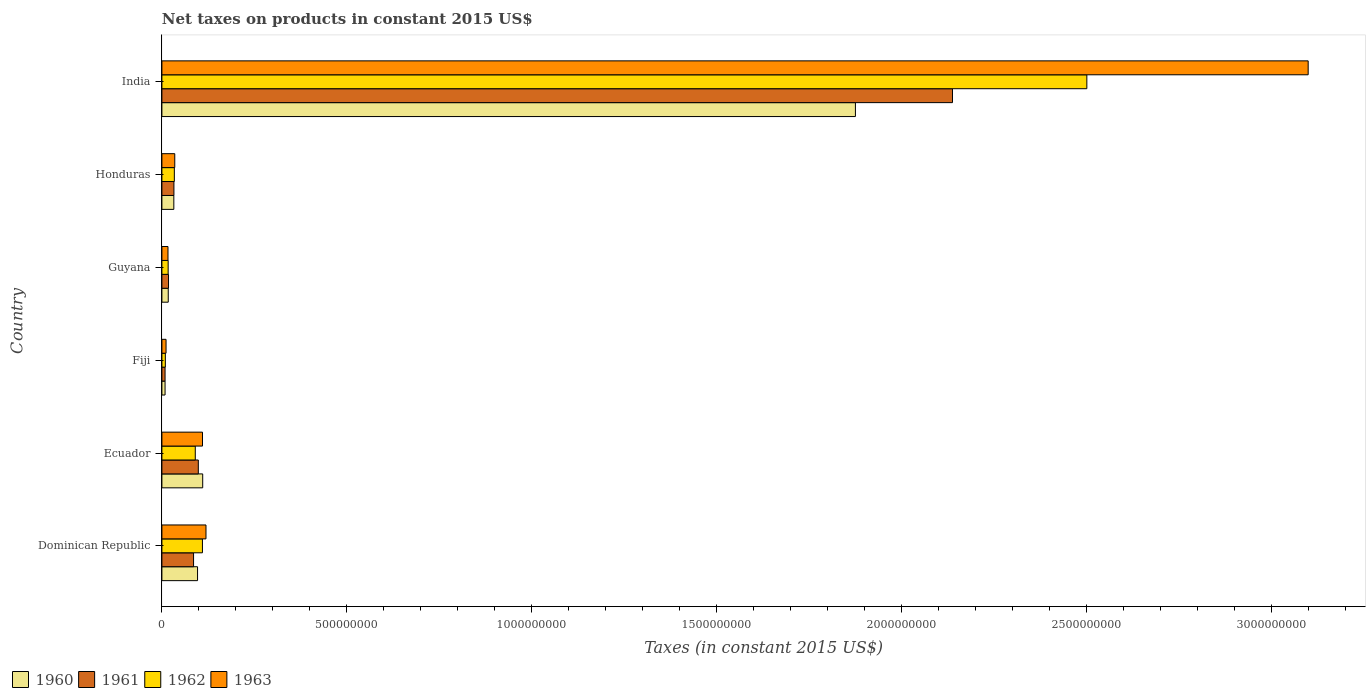Are the number of bars on each tick of the Y-axis equal?
Keep it short and to the point. Yes. How many bars are there on the 2nd tick from the top?
Keep it short and to the point. 4. In how many cases, is the number of bars for a given country not equal to the number of legend labels?
Give a very brief answer. 0. What is the net taxes on products in 1960 in Fiji?
Offer a very short reply. 8.56e+06. Across all countries, what is the maximum net taxes on products in 1963?
Keep it short and to the point. 3.10e+09. Across all countries, what is the minimum net taxes on products in 1960?
Your answer should be very brief. 8.56e+06. In which country was the net taxes on products in 1962 maximum?
Give a very brief answer. India. In which country was the net taxes on products in 1961 minimum?
Provide a short and direct response. Fiji. What is the total net taxes on products in 1962 in the graph?
Your answer should be very brief. 2.76e+09. What is the difference between the net taxes on products in 1963 in Dominican Republic and that in Ecuador?
Keep it short and to the point. 9.44e+06. What is the difference between the net taxes on products in 1960 in India and the net taxes on products in 1962 in Honduras?
Offer a very short reply. 1.84e+09. What is the average net taxes on products in 1963 per country?
Your answer should be compact. 5.65e+08. What is the difference between the net taxes on products in 1963 and net taxes on products in 1961 in Guyana?
Give a very brief answer. -1.46e+06. In how many countries, is the net taxes on products in 1961 greater than 2600000000 US$?
Provide a short and direct response. 0. What is the ratio of the net taxes on products in 1960 in Dominican Republic to that in Honduras?
Provide a short and direct response. 2.99. Is the net taxes on products in 1962 in Fiji less than that in India?
Provide a succinct answer. Yes. Is the difference between the net taxes on products in 1963 in Honduras and India greater than the difference between the net taxes on products in 1961 in Honduras and India?
Make the answer very short. No. What is the difference between the highest and the second highest net taxes on products in 1962?
Your answer should be very brief. 2.39e+09. What is the difference between the highest and the lowest net taxes on products in 1962?
Ensure brevity in your answer.  2.49e+09. Is the sum of the net taxes on products in 1963 in Dominican Republic and India greater than the maximum net taxes on products in 1961 across all countries?
Your response must be concise. Yes. Is it the case that in every country, the sum of the net taxes on products in 1962 and net taxes on products in 1960 is greater than the sum of net taxes on products in 1963 and net taxes on products in 1961?
Your answer should be compact. No. What does the 2nd bar from the bottom in Honduras represents?
Give a very brief answer. 1961. Is it the case that in every country, the sum of the net taxes on products in 1963 and net taxes on products in 1960 is greater than the net taxes on products in 1961?
Ensure brevity in your answer.  Yes. How many bars are there?
Provide a short and direct response. 24. Are all the bars in the graph horizontal?
Give a very brief answer. Yes. How many countries are there in the graph?
Make the answer very short. 6. What is the difference between two consecutive major ticks on the X-axis?
Your answer should be very brief. 5.00e+08. Does the graph contain grids?
Provide a short and direct response. No. What is the title of the graph?
Give a very brief answer. Net taxes on products in constant 2015 US$. What is the label or title of the X-axis?
Provide a short and direct response. Taxes (in constant 2015 US$). What is the Taxes (in constant 2015 US$) of 1960 in Dominican Republic?
Keep it short and to the point. 9.64e+07. What is the Taxes (in constant 2015 US$) of 1961 in Dominican Republic?
Give a very brief answer. 8.56e+07. What is the Taxes (in constant 2015 US$) in 1962 in Dominican Republic?
Provide a succinct answer. 1.10e+08. What is the Taxes (in constant 2015 US$) in 1963 in Dominican Republic?
Offer a very short reply. 1.19e+08. What is the Taxes (in constant 2015 US$) of 1960 in Ecuador?
Keep it short and to the point. 1.10e+08. What is the Taxes (in constant 2015 US$) in 1961 in Ecuador?
Ensure brevity in your answer.  9.85e+07. What is the Taxes (in constant 2015 US$) in 1962 in Ecuador?
Give a very brief answer. 9.03e+07. What is the Taxes (in constant 2015 US$) in 1963 in Ecuador?
Your answer should be very brief. 1.10e+08. What is the Taxes (in constant 2015 US$) of 1960 in Fiji?
Offer a very short reply. 8.56e+06. What is the Taxes (in constant 2015 US$) of 1961 in Fiji?
Your response must be concise. 8.56e+06. What is the Taxes (in constant 2015 US$) of 1962 in Fiji?
Provide a succinct answer. 9.32e+06. What is the Taxes (in constant 2015 US$) in 1963 in Fiji?
Ensure brevity in your answer.  1.12e+07. What is the Taxes (in constant 2015 US$) in 1960 in Guyana?
Provide a succinct answer. 1.71e+07. What is the Taxes (in constant 2015 US$) in 1961 in Guyana?
Your answer should be compact. 1.79e+07. What is the Taxes (in constant 2015 US$) of 1962 in Guyana?
Your response must be concise. 1.69e+07. What is the Taxes (in constant 2015 US$) of 1963 in Guyana?
Provide a short and direct response. 1.64e+07. What is the Taxes (in constant 2015 US$) of 1960 in Honduras?
Offer a very short reply. 3.22e+07. What is the Taxes (in constant 2015 US$) in 1961 in Honduras?
Make the answer very short. 3.25e+07. What is the Taxes (in constant 2015 US$) in 1962 in Honduras?
Ensure brevity in your answer.  3.36e+07. What is the Taxes (in constant 2015 US$) in 1963 in Honduras?
Give a very brief answer. 3.48e+07. What is the Taxes (in constant 2015 US$) in 1960 in India?
Make the answer very short. 1.88e+09. What is the Taxes (in constant 2015 US$) in 1961 in India?
Ensure brevity in your answer.  2.14e+09. What is the Taxes (in constant 2015 US$) in 1962 in India?
Your answer should be very brief. 2.50e+09. What is the Taxes (in constant 2015 US$) in 1963 in India?
Make the answer very short. 3.10e+09. Across all countries, what is the maximum Taxes (in constant 2015 US$) in 1960?
Your answer should be compact. 1.88e+09. Across all countries, what is the maximum Taxes (in constant 2015 US$) in 1961?
Your response must be concise. 2.14e+09. Across all countries, what is the maximum Taxes (in constant 2015 US$) of 1962?
Your response must be concise. 2.50e+09. Across all countries, what is the maximum Taxes (in constant 2015 US$) in 1963?
Give a very brief answer. 3.10e+09. Across all countries, what is the minimum Taxes (in constant 2015 US$) in 1960?
Your response must be concise. 8.56e+06. Across all countries, what is the minimum Taxes (in constant 2015 US$) in 1961?
Offer a very short reply. 8.56e+06. Across all countries, what is the minimum Taxes (in constant 2015 US$) of 1962?
Offer a very short reply. 9.32e+06. Across all countries, what is the minimum Taxes (in constant 2015 US$) of 1963?
Offer a terse response. 1.12e+07. What is the total Taxes (in constant 2015 US$) of 1960 in the graph?
Ensure brevity in your answer.  2.14e+09. What is the total Taxes (in constant 2015 US$) of 1961 in the graph?
Your response must be concise. 2.38e+09. What is the total Taxes (in constant 2015 US$) of 1962 in the graph?
Provide a short and direct response. 2.76e+09. What is the total Taxes (in constant 2015 US$) in 1963 in the graph?
Your response must be concise. 3.39e+09. What is the difference between the Taxes (in constant 2015 US$) of 1960 in Dominican Republic and that in Ecuador?
Your answer should be very brief. -1.39e+07. What is the difference between the Taxes (in constant 2015 US$) in 1961 in Dominican Republic and that in Ecuador?
Your answer should be compact. -1.29e+07. What is the difference between the Taxes (in constant 2015 US$) in 1962 in Dominican Republic and that in Ecuador?
Provide a short and direct response. 1.93e+07. What is the difference between the Taxes (in constant 2015 US$) in 1963 in Dominican Republic and that in Ecuador?
Give a very brief answer. 9.44e+06. What is the difference between the Taxes (in constant 2015 US$) of 1960 in Dominican Republic and that in Fiji?
Provide a succinct answer. 8.78e+07. What is the difference between the Taxes (in constant 2015 US$) of 1961 in Dominican Republic and that in Fiji?
Ensure brevity in your answer.  7.70e+07. What is the difference between the Taxes (in constant 2015 US$) of 1962 in Dominican Republic and that in Fiji?
Give a very brief answer. 1.00e+08. What is the difference between the Taxes (in constant 2015 US$) in 1963 in Dominican Republic and that in Fiji?
Offer a terse response. 1.08e+08. What is the difference between the Taxes (in constant 2015 US$) in 1960 in Dominican Republic and that in Guyana?
Offer a terse response. 7.93e+07. What is the difference between the Taxes (in constant 2015 US$) in 1961 in Dominican Republic and that in Guyana?
Make the answer very short. 6.77e+07. What is the difference between the Taxes (in constant 2015 US$) of 1962 in Dominican Republic and that in Guyana?
Ensure brevity in your answer.  9.27e+07. What is the difference between the Taxes (in constant 2015 US$) of 1963 in Dominican Republic and that in Guyana?
Provide a succinct answer. 1.03e+08. What is the difference between the Taxes (in constant 2015 US$) of 1960 in Dominican Republic and that in Honduras?
Provide a short and direct response. 6.42e+07. What is the difference between the Taxes (in constant 2015 US$) of 1961 in Dominican Republic and that in Honduras?
Your answer should be very brief. 5.31e+07. What is the difference between the Taxes (in constant 2015 US$) in 1962 in Dominican Republic and that in Honduras?
Provide a short and direct response. 7.60e+07. What is the difference between the Taxes (in constant 2015 US$) in 1963 in Dominican Republic and that in Honduras?
Your response must be concise. 8.44e+07. What is the difference between the Taxes (in constant 2015 US$) of 1960 in Dominican Republic and that in India?
Give a very brief answer. -1.78e+09. What is the difference between the Taxes (in constant 2015 US$) in 1961 in Dominican Republic and that in India?
Offer a very short reply. -2.05e+09. What is the difference between the Taxes (in constant 2015 US$) of 1962 in Dominican Republic and that in India?
Ensure brevity in your answer.  -2.39e+09. What is the difference between the Taxes (in constant 2015 US$) in 1963 in Dominican Republic and that in India?
Your answer should be very brief. -2.98e+09. What is the difference between the Taxes (in constant 2015 US$) in 1960 in Ecuador and that in Fiji?
Offer a terse response. 1.02e+08. What is the difference between the Taxes (in constant 2015 US$) of 1961 in Ecuador and that in Fiji?
Provide a short and direct response. 8.99e+07. What is the difference between the Taxes (in constant 2015 US$) of 1962 in Ecuador and that in Fiji?
Make the answer very short. 8.09e+07. What is the difference between the Taxes (in constant 2015 US$) in 1963 in Ecuador and that in Fiji?
Provide a short and direct response. 9.86e+07. What is the difference between the Taxes (in constant 2015 US$) of 1960 in Ecuador and that in Guyana?
Provide a succinct answer. 9.32e+07. What is the difference between the Taxes (in constant 2015 US$) in 1961 in Ecuador and that in Guyana?
Your answer should be very brief. 8.06e+07. What is the difference between the Taxes (in constant 2015 US$) of 1962 in Ecuador and that in Guyana?
Keep it short and to the point. 7.33e+07. What is the difference between the Taxes (in constant 2015 US$) in 1963 in Ecuador and that in Guyana?
Give a very brief answer. 9.33e+07. What is the difference between the Taxes (in constant 2015 US$) of 1960 in Ecuador and that in Honduras?
Offer a very short reply. 7.81e+07. What is the difference between the Taxes (in constant 2015 US$) of 1961 in Ecuador and that in Honduras?
Keep it short and to the point. 6.60e+07. What is the difference between the Taxes (in constant 2015 US$) in 1962 in Ecuador and that in Honduras?
Your answer should be compact. 5.66e+07. What is the difference between the Taxes (in constant 2015 US$) in 1963 in Ecuador and that in Honduras?
Your response must be concise. 7.50e+07. What is the difference between the Taxes (in constant 2015 US$) in 1960 in Ecuador and that in India?
Your answer should be compact. -1.76e+09. What is the difference between the Taxes (in constant 2015 US$) of 1961 in Ecuador and that in India?
Provide a succinct answer. -2.04e+09. What is the difference between the Taxes (in constant 2015 US$) of 1962 in Ecuador and that in India?
Offer a very short reply. -2.41e+09. What is the difference between the Taxes (in constant 2015 US$) of 1963 in Ecuador and that in India?
Your answer should be very brief. -2.99e+09. What is the difference between the Taxes (in constant 2015 US$) in 1960 in Fiji and that in Guyana?
Provide a succinct answer. -8.59e+06. What is the difference between the Taxes (in constant 2015 US$) of 1961 in Fiji and that in Guyana?
Provide a succinct answer. -9.34e+06. What is the difference between the Taxes (in constant 2015 US$) of 1962 in Fiji and that in Guyana?
Your answer should be compact. -7.60e+06. What is the difference between the Taxes (in constant 2015 US$) of 1963 in Fiji and that in Guyana?
Your response must be concise. -5.24e+06. What is the difference between the Taxes (in constant 2015 US$) in 1960 in Fiji and that in Honduras?
Keep it short and to the point. -2.37e+07. What is the difference between the Taxes (in constant 2015 US$) in 1961 in Fiji and that in Honduras?
Provide a succinct answer. -2.39e+07. What is the difference between the Taxes (in constant 2015 US$) in 1962 in Fiji and that in Honduras?
Your answer should be compact. -2.43e+07. What is the difference between the Taxes (in constant 2015 US$) in 1963 in Fiji and that in Honduras?
Offer a very short reply. -2.36e+07. What is the difference between the Taxes (in constant 2015 US$) of 1960 in Fiji and that in India?
Provide a succinct answer. -1.87e+09. What is the difference between the Taxes (in constant 2015 US$) of 1961 in Fiji and that in India?
Provide a short and direct response. -2.13e+09. What is the difference between the Taxes (in constant 2015 US$) in 1962 in Fiji and that in India?
Your answer should be very brief. -2.49e+09. What is the difference between the Taxes (in constant 2015 US$) of 1963 in Fiji and that in India?
Offer a very short reply. -3.09e+09. What is the difference between the Taxes (in constant 2015 US$) of 1960 in Guyana and that in Honduras?
Give a very brief answer. -1.51e+07. What is the difference between the Taxes (in constant 2015 US$) in 1961 in Guyana and that in Honduras?
Give a very brief answer. -1.46e+07. What is the difference between the Taxes (in constant 2015 US$) of 1962 in Guyana and that in Honduras?
Your answer should be very brief. -1.67e+07. What is the difference between the Taxes (in constant 2015 US$) of 1963 in Guyana and that in Honduras?
Provide a short and direct response. -1.84e+07. What is the difference between the Taxes (in constant 2015 US$) in 1960 in Guyana and that in India?
Offer a very short reply. -1.86e+09. What is the difference between the Taxes (in constant 2015 US$) of 1961 in Guyana and that in India?
Your answer should be very brief. -2.12e+09. What is the difference between the Taxes (in constant 2015 US$) of 1962 in Guyana and that in India?
Offer a terse response. -2.48e+09. What is the difference between the Taxes (in constant 2015 US$) in 1963 in Guyana and that in India?
Ensure brevity in your answer.  -3.08e+09. What is the difference between the Taxes (in constant 2015 US$) in 1960 in Honduras and that in India?
Make the answer very short. -1.84e+09. What is the difference between the Taxes (in constant 2015 US$) of 1961 in Honduras and that in India?
Give a very brief answer. -2.11e+09. What is the difference between the Taxes (in constant 2015 US$) in 1962 in Honduras and that in India?
Provide a succinct answer. -2.47e+09. What is the difference between the Taxes (in constant 2015 US$) in 1963 in Honduras and that in India?
Give a very brief answer. -3.06e+09. What is the difference between the Taxes (in constant 2015 US$) of 1960 in Dominican Republic and the Taxes (in constant 2015 US$) of 1961 in Ecuador?
Your answer should be compact. -2.07e+06. What is the difference between the Taxes (in constant 2015 US$) in 1960 in Dominican Republic and the Taxes (in constant 2015 US$) in 1962 in Ecuador?
Make the answer very short. 6.14e+06. What is the difference between the Taxes (in constant 2015 US$) in 1960 in Dominican Republic and the Taxes (in constant 2015 US$) in 1963 in Ecuador?
Provide a succinct answer. -1.34e+07. What is the difference between the Taxes (in constant 2015 US$) of 1961 in Dominican Republic and the Taxes (in constant 2015 US$) of 1962 in Ecuador?
Give a very brief answer. -4.66e+06. What is the difference between the Taxes (in constant 2015 US$) of 1961 in Dominican Republic and the Taxes (in constant 2015 US$) of 1963 in Ecuador?
Your response must be concise. -2.42e+07. What is the difference between the Taxes (in constant 2015 US$) of 1962 in Dominican Republic and the Taxes (in constant 2015 US$) of 1963 in Ecuador?
Make the answer very short. -1.64e+05. What is the difference between the Taxes (in constant 2015 US$) in 1960 in Dominican Republic and the Taxes (in constant 2015 US$) in 1961 in Fiji?
Offer a very short reply. 8.78e+07. What is the difference between the Taxes (in constant 2015 US$) of 1960 in Dominican Republic and the Taxes (in constant 2015 US$) of 1962 in Fiji?
Ensure brevity in your answer.  8.71e+07. What is the difference between the Taxes (in constant 2015 US$) in 1960 in Dominican Republic and the Taxes (in constant 2015 US$) in 1963 in Fiji?
Give a very brief answer. 8.52e+07. What is the difference between the Taxes (in constant 2015 US$) of 1961 in Dominican Republic and the Taxes (in constant 2015 US$) of 1962 in Fiji?
Your answer should be very brief. 7.63e+07. What is the difference between the Taxes (in constant 2015 US$) in 1961 in Dominican Republic and the Taxes (in constant 2015 US$) in 1963 in Fiji?
Provide a succinct answer. 7.44e+07. What is the difference between the Taxes (in constant 2015 US$) in 1962 in Dominican Republic and the Taxes (in constant 2015 US$) in 1963 in Fiji?
Keep it short and to the point. 9.84e+07. What is the difference between the Taxes (in constant 2015 US$) in 1960 in Dominican Republic and the Taxes (in constant 2015 US$) in 1961 in Guyana?
Keep it short and to the point. 7.85e+07. What is the difference between the Taxes (in constant 2015 US$) of 1960 in Dominican Republic and the Taxes (in constant 2015 US$) of 1962 in Guyana?
Your response must be concise. 7.95e+07. What is the difference between the Taxes (in constant 2015 US$) in 1960 in Dominican Republic and the Taxes (in constant 2015 US$) in 1963 in Guyana?
Ensure brevity in your answer.  8.00e+07. What is the difference between the Taxes (in constant 2015 US$) in 1961 in Dominican Republic and the Taxes (in constant 2015 US$) in 1962 in Guyana?
Give a very brief answer. 6.87e+07. What is the difference between the Taxes (in constant 2015 US$) in 1961 in Dominican Republic and the Taxes (in constant 2015 US$) in 1963 in Guyana?
Keep it short and to the point. 6.92e+07. What is the difference between the Taxes (in constant 2015 US$) of 1962 in Dominican Republic and the Taxes (in constant 2015 US$) of 1963 in Guyana?
Your answer should be compact. 9.32e+07. What is the difference between the Taxes (in constant 2015 US$) of 1960 in Dominican Republic and the Taxes (in constant 2015 US$) of 1961 in Honduras?
Your answer should be compact. 6.39e+07. What is the difference between the Taxes (in constant 2015 US$) in 1960 in Dominican Republic and the Taxes (in constant 2015 US$) in 1962 in Honduras?
Keep it short and to the point. 6.28e+07. What is the difference between the Taxes (in constant 2015 US$) of 1960 in Dominican Republic and the Taxes (in constant 2015 US$) of 1963 in Honduras?
Provide a short and direct response. 6.16e+07. What is the difference between the Taxes (in constant 2015 US$) in 1961 in Dominican Republic and the Taxes (in constant 2015 US$) in 1962 in Honduras?
Your answer should be compact. 5.20e+07. What is the difference between the Taxes (in constant 2015 US$) in 1961 in Dominican Republic and the Taxes (in constant 2015 US$) in 1963 in Honduras?
Provide a succinct answer. 5.08e+07. What is the difference between the Taxes (in constant 2015 US$) in 1962 in Dominican Republic and the Taxes (in constant 2015 US$) in 1963 in Honduras?
Provide a short and direct response. 7.48e+07. What is the difference between the Taxes (in constant 2015 US$) of 1960 in Dominican Republic and the Taxes (in constant 2015 US$) of 1961 in India?
Ensure brevity in your answer.  -2.04e+09. What is the difference between the Taxes (in constant 2015 US$) in 1960 in Dominican Republic and the Taxes (in constant 2015 US$) in 1962 in India?
Give a very brief answer. -2.40e+09. What is the difference between the Taxes (in constant 2015 US$) in 1960 in Dominican Republic and the Taxes (in constant 2015 US$) in 1963 in India?
Provide a succinct answer. -3.00e+09. What is the difference between the Taxes (in constant 2015 US$) in 1961 in Dominican Republic and the Taxes (in constant 2015 US$) in 1962 in India?
Offer a terse response. -2.42e+09. What is the difference between the Taxes (in constant 2015 US$) of 1961 in Dominican Republic and the Taxes (in constant 2015 US$) of 1963 in India?
Ensure brevity in your answer.  -3.01e+09. What is the difference between the Taxes (in constant 2015 US$) in 1962 in Dominican Republic and the Taxes (in constant 2015 US$) in 1963 in India?
Your answer should be very brief. -2.99e+09. What is the difference between the Taxes (in constant 2015 US$) of 1960 in Ecuador and the Taxes (in constant 2015 US$) of 1961 in Fiji?
Your answer should be very brief. 1.02e+08. What is the difference between the Taxes (in constant 2015 US$) in 1960 in Ecuador and the Taxes (in constant 2015 US$) in 1962 in Fiji?
Your answer should be compact. 1.01e+08. What is the difference between the Taxes (in constant 2015 US$) in 1960 in Ecuador and the Taxes (in constant 2015 US$) in 1963 in Fiji?
Provide a short and direct response. 9.91e+07. What is the difference between the Taxes (in constant 2015 US$) in 1961 in Ecuador and the Taxes (in constant 2015 US$) in 1962 in Fiji?
Offer a terse response. 8.91e+07. What is the difference between the Taxes (in constant 2015 US$) in 1961 in Ecuador and the Taxes (in constant 2015 US$) in 1963 in Fiji?
Make the answer very short. 8.73e+07. What is the difference between the Taxes (in constant 2015 US$) of 1962 in Ecuador and the Taxes (in constant 2015 US$) of 1963 in Fiji?
Your answer should be very brief. 7.91e+07. What is the difference between the Taxes (in constant 2015 US$) of 1960 in Ecuador and the Taxes (in constant 2015 US$) of 1961 in Guyana?
Give a very brief answer. 9.24e+07. What is the difference between the Taxes (in constant 2015 US$) of 1960 in Ecuador and the Taxes (in constant 2015 US$) of 1962 in Guyana?
Ensure brevity in your answer.  9.34e+07. What is the difference between the Taxes (in constant 2015 US$) in 1960 in Ecuador and the Taxes (in constant 2015 US$) in 1963 in Guyana?
Your response must be concise. 9.39e+07. What is the difference between the Taxes (in constant 2015 US$) in 1961 in Ecuador and the Taxes (in constant 2015 US$) in 1962 in Guyana?
Keep it short and to the point. 8.16e+07. What is the difference between the Taxes (in constant 2015 US$) of 1961 in Ecuador and the Taxes (in constant 2015 US$) of 1963 in Guyana?
Your answer should be very brief. 8.20e+07. What is the difference between the Taxes (in constant 2015 US$) of 1962 in Ecuador and the Taxes (in constant 2015 US$) of 1963 in Guyana?
Offer a very short reply. 7.38e+07. What is the difference between the Taxes (in constant 2015 US$) in 1960 in Ecuador and the Taxes (in constant 2015 US$) in 1961 in Honduras?
Keep it short and to the point. 7.78e+07. What is the difference between the Taxes (in constant 2015 US$) of 1960 in Ecuador and the Taxes (in constant 2015 US$) of 1962 in Honduras?
Offer a very short reply. 7.67e+07. What is the difference between the Taxes (in constant 2015 US$) in 1960 in Ecuador and the Taxes (in constant 2015 US$) in 1963 in Honduras?
Ensure brevity in your answer.  7.55e+07. What is the difference between the Taxes (in constant 2015 US$) of 1961 in Ecuador and the Taxes (in constant 2015 US$) of 1962 in Honduras?
Provide a short and direct response. 6.48e+07. What is the difference between the Taxes (in constant 2015 US$) in 1961 in Ecuador and the Taxes (in constant 2015 US$) in 1963 in Honduras?
Ensure brevity in your answer.  6.37e+07. What is the difference between the Taxes (in constant 2015 US$) in 1962 in Ecuador and the Taxes (in constant 2015 US$) in 1963 in Honduras?
Offer a very short reply. 5.55e+07. What is the difference between the Taxes (in constant 2015 US$) in 1960 in Ecuador and the Taxes (in constant 2015 US$) in 1961 in India?
Provide a short and direct response. -2.03e+09. What is the difference between the Taxes (in constant 2015 US$) in 1960 in Ecuador and the Taxes (in constant 2015 US$) in 1962 in India?
Provide a short and direct response. -2.39e+09. What is the difference between the Taxes (in constant 2015 US$) in 1960 in Ecuador and the Taxes (in constant 2015 US$) in 1963 in India?
Make the answer very short. -2.99e+09. What is the difference between the Taxes (in constant 2015 US$) of 1961 in Ecuador and the Taxes (in constant 2015 US$) of 1962 in India?
Provide a succinct answer. -2.40e+09. What is the difference between the Taxes (in constant 2015 US$) of 1961 in Ecuador and the Taxes (in constant 2015 US$) of 1963 in India?
Offer a terse response. -3.00e+09. What is the difference between the Taxes (in constant 2015 US$) of 1962 in Ecuador and the Taxes (in constant 2015 US$) of 1963 in India?
Keep it short and to the point. -3.01e+09. What is the difference between the Taxes (in constant 2015 US$) in 1960 in Fiji and the Taxes (in constant 2015 US$) in 1961 in Guyana?
Your answer should be compact. -9.34e+06. What is the difference between the Taxes (in constant 2015 US$) of 1960 in Fiji and the Taxes (in constant 2015 US$) of 1962 in Guyana?
Your response must be concise. -8.35e+06. What is the difference between the Taxes (in constant 2015 US$) in 1960 in Fiji and the Taxes (in constant 2015 US$) in 1963 in Guyana?
Ensure brevity in your answer.  -7.89e+06. What is the difference between the Taxes (in constant 2015 US$) of 1961 in Fiji and the Taxes (in constant 2015 US$) of 1962 in Guyana?
Give a very brief answer. -8.35e+06. What is the difference between the Taxes (in constant 2015 US$) in 1961 in Fiji and the Taxes (in constant 2015 US$) in 1963 in Guyana?
Offer a very short reply. -7.89e+06. What is the difference between the Taxes (in constant 2015 US$) of 1962 in Fiji and the Taxes (in constant 2015 US$) of 1963 in Guyana?
Offer a terse response. -7.13e+06. What is the difference between the Taxes (in constant 2015 US$) of 1960 in Fiji and the Taxes (in constant 2015 US$) of 1961 in Honduras?
Offer a terse response. -2.39e+07. What is the difference between the Taxes (in constant 2015 US$) in 1960 in Fiji and the Taxes (in constant 2015 US$) in 1962 in Honduras?
Offer a terse response. -2.51e+07. What is the difference between the Taxes (in constant 2015 US$) in 1960 in Fiji and the Taxes (in constant 2015 US$) in 1963 in Honduras?
Offer a very short reply. -2.62e+07. What is the difference between the Taxes (in constant 2015 US$) in 1961 in Fiji and the Taxes (in constant 2015 US$) in 1962 in Honduras?
Your response must be concise. -2.51e+07. What is the difference between the Taxes (in constant 2015 US$) in 1961 in Fiji and the Taxes (in constant 2015 US$) in 1963 in Honduras?
Ensure brevity in your answer.  -2.62e+07. What is the difference between the Taxes (in constant 2015 US$) of 1962 in Fiji and the Taxes (in constant 2015 US$) of 1963 in Honduras?
Provide a succinct answer. -2.55e+07. What is the difference between the Taxes (in constant 2015 US$) in 1960 in Fiji and the Taxes (in constant 2015 US$) in 1961 in India?
Provide a succinct answer. -2.13e+09. What is the difference between the Taxes (in constant 2015 US$) of 1960 in Fiji and the Taxes (in constant 2015 US$) of 1962 in India?
Keep it short and to the point. -2.49e+09. What is the difference between the Taxes (in constant 2015 US$) in 1960 in Fiji and the Taxes (in constant 2015 US$) in 1963 in India?
Make the answer very short. -3.09e+09. What is the difference between the Taxes (in constant 2015 US$) of 1961 in Fiji and the Taxes (in constant 2015 US$) of 1962 in India?
Provide a succinct answer. -2.49e+09. What is the difference between the Taxes (in constant 2015 US$) in 1961 in Fiji and the Taxes (in constant 2015 US$) in 1963 in India?
Make the answer very short. -3.09e+09. What is the difference between the Taxes (in constant 2015 US$) of 1962 in Fiji and the Taxes (in constant 2015 US$) of 1963 in India?
Provide a succinct answer. -3.09e+09. What is the difference between the Taxes (in constant 2015 US$) in 1960 in Guyana and the Taxes (in constant 2015 US$) in 1961 in Honduras?
Provide a succinct answer. -1.54e+07. What is the difference between the Taxes (in constant 2015 US$) in 1960 in Guyana and the Taxes (in constant 2015 US$) in 1962 in Honduras?
Make the answer very short. -1.65e+07. What is the difference between the Taxes (in constant 2015 US$) of 1960 in Guyana and the Taxes (in constant 2015 US$) of 1963 in Honduras?
Your response must be concise. -1.77e+07. What is the difference between the Taxes (in constant 2015 US$) in 1961 in Guyana and the Taxes (in constant 2015 US$) in 1962 in Honduras?
Ensure brevity in your answer.  -1.57e+07. What is the difference between the Taxes (in constant 2015 US$) in 1961 in Guyana and the Taxes (in constant 2015 US$) in 1963 in Honduras?
Make the answer very short. -1.69e+07. What is the difference between the Taxes (in constant 2015 US$) in 1962 in Guyana and the Taxes (in constant 2015 US$) in 1963 in Honduras?
Offer a terse response. -1.79e+07. What is the difference between the Taxes (in constant 2015 US$) in 1960 in Guyana and the Taxes (in constant 2015 US$) in 1961 in India?
Ensure brevity in your answer.  -2.12e+09. What is the difference between the Taxes (in constant 2015 US$) of 1960 in Guyana and the Taxes (in constant 2015 US$) of 1962 in India?
Provide a short and direct response. -2.48e+09. What is the difference between the Taxes (in constant 2015 US$) of 1960 in Guyana and the Taxes (in constant 2015 US$) of 1963 in India?
Offer a terse response. -3.08e+09. What is the difference between the Taxes (in constant 2015 US$) in 1961 in Guyana and the Taxes (in constant 2015 US$) in 1962 in India?
Offer a very short reply. -2.48e+09. What is the difference between the Taxes (in constant 2015 US$) in 1961 in Guyana and the Taxes (in constant 2015 US$) in 1963 in India?
Provide a short and direct response. -3.08e+09. What is the difference between the Taxes (in constant 2015 US$) in 1962 in Guyana and the Taxes (in constant 2015 US$) in 1963 in India?
Make the answer very short. -3.08e+09. What is the difference between the Taxes (in constant 2015 US$) in 1960 in Honduras and the Taxes (in constant 2015 US$) in 1961 in India?
Keep it short and to the point. -2.11e+09. What is the difference between the Taxes (in constant 2015 US$) in 1960 in Honduras and the Taxes (in constant 2015 US$) in 1962 in India?
Ensure brevity in your answer.  -2.47e+09. What is the difference between the Taxes (in constant 2015 US$) of 1960 in Honduras and the Taxes (in constant 2015 US$) of 1963 in India?
Give a very brief answer. -3.07e+09. What is the difference between the Taxes (in constant 2015 US$) in 1961 in Honduras and the Taxes (in constant 2015 US$) in 1962 in India?
Make the answer very short. -2.47e+09. What is the difference between the Taxes (in constant 2015 US$) of 1961 in Honduras and the Taxes (in constant 2015 US$) of 1963 in India?
Your answer should be very brief. -3.07e+09. What is the difference between the Taxes (in constant 2015 US$) of 1962 in Honduras and the Taxes (in constant 2015 US$) of 1963 in India?
Offer a terse response. -3.07e+09. What is the average Taxes (in constant 2015 US$) in 1960 per country?
Provide a succinct answer. 3.57e+08. What is the average Taxes (in constant 2015 US$) of 1961 per country?
Give a very brief answer. 3.97e+08. What is the average Taxes (in constant 2015 US$) of 1962 per country?
Ensure brevity in your answer.  4.60e+08. What is the average Taxes (in constant 2015 US$) in 1963 per country?
Provide a succinct answer. 5.65e+08. What is the difference between the Taxes (in constant 2015 US$) of 1960 and Taxes (in constant 2015 US$) of 1961 in Dominican Republic?
Your response must be concise. 1.08e+07. What is the difference between the Taxes (in constant 2015 US$) in 1960 and Taxes (in constant 2015 US$) in 1962 in Dominican Republic?
Offer a very short reply. -1.32e+07. What is the difference between the Taxes (in constant 2015 US$) in 1960 and Taxes (in constant 2015 US$) in 1963 in Dominican Republic?
Provide a succinct answer. -2.28e+07. What is the difference between the Taxes (in constant 2015 US$) of 1961 and Taxes (in constant 2015 US$) of 1962 in Dominican Republic?
Offer a very short reply. -2.40e+07. What is the difference between the Taxes (in constant 2015 US$) in 1961 and Taxes (in constant 2015 US$) in 1963 in Dominican Republic?
Provide a succinct answer. -3.36e+07. What is the difference between the Taxes (in constant 2015 US$) in 1962 and Taxes (in constant 2015 US$) in 1963 in Dominican Republic?
Your response must be concise. -9.60e+06. What is the difference between the Taxes (in constant 2015 US$) of 1960 and Taxes (in constant 2015 US$) of 1961 in Ecuador?
Offer a terse response. 1.19e+07. What is the difference between the Taxes (in constant 2015 US$) in 1960 and Taxes (in constant 2015 US$) in 1962 in Ecuador?
Your answer should be very brief. 2.01e+07. What is the difference between the Taxes (in constant 2015 US$) of 1960 and Taxes (in constant 2015 US$) of 1963 in Ecuador?
Your response must be concise. 5.57e+05. What is the difference between the Taxes (in constant 2015 US$) in 1961 and Taxes (in constant 2015 US$) in 1962 in Ecuador?
Provide a succinct answer. 8.21e+06. What is the difference between the Taxes (in constant 2015 US$) in 1961 and Taxes (in constant 2015 US$) in 1963 in Ecuador?
Your response must be concise. -1.13e+07. What is the difference between the Taxes (in constant 2015 US$) in 1962 and Taxes (in constant 2015 US$) in 1963 in Ecuador?
Provide a succinct answer. -1.95e+07. What is the difference between the Taxes (in constant 2015 US$) in 1960 and Taxes (in constant 2015 US$) in 1962 in Fiji?
Offer a very short reply. -7.56e+05. What is the difference between the Taxes (in constant 2015 US$) of 1960 and Taxes (in constant 2015 US$) of 1963 in Fiji?
Your answer should be very brief. -2.64e+06. What is the difference between the Taxes (in constant 2015 US$) of 1961 and Taxes (in constant 2015 US$) of 1962 in Fiji?
Your response must be concise. -7.56e+05. What is the difference between the Taxes (in constant 2015 US$) of 1961 and Taxes (in constant 2015 US$) of 1963 in Fiji?
Provide a succinct answer. -2.64e+06. What is the difference between the Taxes (in constant 2015 US$) in 1962 and Taxes (in constant 2015 US$) in 1963 in Fiji?
Offer a very short reply. -1.89e+06. What is the difference between the Taxes (in constant 2015 US$) of 1960 and Taxes (in constant 2015 US$) of 1961 in Guyana?
Offer a terse response. -7.58e+05. What is the difference between the Taxes (in constant 2015 US$) in 1960 and Taxes (in constant 2015 US$) in 1962 in Guyana?
Offer a very short reply. 2.33e+05. What is the difference between the Taxes (in constant 2015 US$) of 1960 and Taxes (in constant 2015 US$) of 1963 in Guyana?
Your answer should be compact. 7.00e+05. What is the difference between the Taxes (in constant 2015 US$) in 1961 and Taxes (in constant 2015 US$) in 1962 in Guyana?
Offer a terse response. 9.92e+05. What is the difference between the Taxes (in constant 2015 US$) of 1961 and Taxes (in constant 2015 US$) of 1963 in Guyana?
Give a very brief answer. 1.46e+06. What is the difference between the Taxes (in constant 2015 US$) in 1962 and Taxes (in constant 2015 US$) in 1963 in Guyana?
Make the answer very short. 4.67e+05. What is the difference between the Taxes (in constant 2015 US$) of 1960 and Taxes (in constant 2015 US$) of 1962 in Honduras?
Ensure brevity in your answer.  -1.40e+06. What is the difference between the Taxes (in constant 2015 US$) in 1960 and Taxes (in constant 2015 US$) in 1963 in Honduras?
Give a very brief answer. -2.55e+06. What is the difference between the Taxes (in constant 2015 US$) of 1961 and Taxes (in constant 2015 US$) of 1962 in Honduras?
Ensure brevity in your answer.  -1.15e+06. What is the difference between the Taxes (in constant 2015 US$) of 1961 and Taxes (in constant 2015 US$) of 1963 in Honduras?
Offer a very short reply. -2.30e+06. What is the difference between the Taxes (in constant 2015 US$) of 1962 and Taxes (in constant 2015 US$) of 1963 in Honduras?
Keep it short and to the point. -1.15e+06. What is the difference between the Taxes (in constant 2015 US$) in 1960 and Taxes (in constant 2015 US$) in 1961 in India?
Ensure brevity in your answer.  -2.63e+08. What is the difference between the Taxes (in constant 2015 US$) of 1960 and Taxes (in constant 2015 US$) of 1962 in India?
Give a very brief answer. -6.26e+08. What is the difference between the Taxes (in constant 2015 US$) in 1960 and Taxes (in constant 2015 US$) in 1963 in India?
Keep it short and to the point. -1.22e+09. What is the difference between the Taxes (in constant 2015 US$) of 1961 and Taxes (in constant 2015 US$) of 1962 in India?
Keep it short and to the point. -3.63e+08. What is the difference between the Taxes (in constant 2015 US$) in 1961 and Taxes (in constant 2015 US$) in 1963 in India?
Offer a very short reply. -9.62e+08. What is the difference between the Taxes (in constant 2015 US$) in 1962 and Taxes (in constant 2015 US$) in 1963 in India?
Your answer should be very brief. -5.99e+08. What is the ratio of the Taxes (in constant 2015 US$) in 1960 in Dominican Republic to that in Ecuador?
Your answer should be compact. 0.87. What is the ratio of the Taxes (in constant 2015 US$) in 1961 in Dominican Republic to that in Ecuador?
Your answer should be very brief. 0.87. What is the ratio of the Taxes (in constant 2015 US$) in 1962 in Dominican Republic to that in Ecuador?
Your response must be concise. 1.21. What is the ratio of the Taxes (in constant 2015 US$) in 1963 in Dominican Republic to that in Ecuador?
Provide a short and direct response. 1.09. What is the ratio of the Taxes (in constant 2015 US$) in 1960 in Dominican Republic to that in Fiji?
Make the answer very short. 11.26. What is the ratio of the Taxes (in constant 2015 US$) in 1961 in Dominican Republic to that in Fiji?
Provide a short and direct response. 10. What is the ratio of the Taxes (in constant 2015 US$) of 1962 in Dominican Republic to that in Fiji?
Provide a succinct answer. 11.76. What is the ratio of the Taxes (in constant 2015 US$) in 1963 in Dominican Republic to that in Fiji?
Offer a very short reply. 10.63. What is the ratio of the Taxes (in constant 2015 US$) in 1960 in Dominican Republic to that in Guyana?
Provide a succinct answer. 5.62. What is the ratio of the Taxes (in constant 2015 US$) of 1961 in Dominican Republic to that in Guyana?
Give a very brief answer. 4.78. What is the ratio of the Taxes (in constant 2015 US$) of 1962 in Dominican Republic to that in Guyana?
Give a very brief answer. 6.48. What is the ratio of the Taxes (in constant 2015 US$) in 1963 in Dominican Republic to that in Guyana?
Keep it short and to the point. 7.25. What is the ratio of the Taxes (in constant 2015 US$) in 1960 in Dominican Republic to that in Honduras?
Your answer should be compact. 2.99. What is the ratio of the Taxes (in constant 2015 US$) in 1961 in Dominican Republic to that in Honduras?
Offer a very short reply. 2.63. What is the ratio of the Taxes (in constant 2015 US$) of 1962 in Dominican Republic to that in Honduras?
Offer a very short reply. 3.26. What is the ratio of the Taxes (in constant 2015 US$) of 1963 in Dominican Republic to that in Honduras?
Your response must be concise. 3.43. What is the ratio of the Taxes (in constant 2015 US$) in 1960 in Dominican Republic to that in India?
Your response must be concise. 0.05. What is the ratio of the Taxes (in constant 2015 US$) of 1962 in Dominican Republic to that in India?
Provide a succinct answer. 0.04. What is the ratio of the Taxes (in constant 2015 US$) of 1963 in Dominican Republic to that in India?
Your answer should be compact. 0.04. What is the ratio of the Taxes (in constant 2015 US$) in 1960 in Ecuador to that in Fiji?
Keep it short and to the point. 12.88. What is the ratio of the Taxes (in constant 2015 US$) of 1961 in Ecuador to that in Fiji?
Provide a succinct answer. 11.5. What is the ratio of the Taxes (in constant 2015 US$) of 1962 in Ecuador to that in Fiji?
Your answer should be compact. 9.69. What is the ratio of the Taxes (in constant 2015 US$) of 1963 in Ecuador to that in Fiji?
Make the answer very short. 9.79. What is the ratio of the Taxes (in constant 2015 US$) in 1960 in Ecuador to that in Guyana?
Provide a succinct answer. 6.43. What is the ratio of the Taxes (in constant 2015 US$) in 1961 in Ecuador to that in Guyana?
Ensure brevity in your answer.  5.5. What is the ratio of the Taxes (in constant 2015 US$) of 1962 in Ecuador to that in Guyana?
Your answer should be compact. 5.34. What is the ratio of the Taxes (in constant 2015 US$) of 1963 in Ecuador to that in Guyana?
Keep it short and to the point. 6.67. What is the ratio of the Taxes (in constant 2015 US$) in 1960 in Ecuador to that in Honduras?
Offer a terse response. 3.42. What is the ratio of the Taxes (in constant 2015 US$) in 1961 in Ecuador to that in Honduras?
Your response must be concise. 3.03. What is the ratio of the Taxes (in constant 2015 US$) of 1962 in Ecuador to that in Honduras?
Provide a succinct answer. 2.68. What is the ratio of the Taxes (in constant 2015 US$) in 1963 in Ecuador to that in Honduras?
Make the answer very short. 3.15. What is the ratio of the Taxes (in constant 2015 US$) in 1960 in Ecuador to that in India?
Ensure brevity in your answer.  0.06. What is the ratio of the Taxes (in constant 2015 US$) in 1961 in Ecuador to that in India?
Make the answer very short. 0.05. What is the ratio of the Taxes (in constant 2015 US$) of 1962 in Ecuador to that in India?
Keep it short and to the point. 0.04. What is the ratio of the Taxes (in constant 2015 US$) in 1963 in Ecuador to that in India?
Offer a very short reply. 0.04. What is the ratio of the Taxes (in constant 2015 US$) in 1960 in Fiji to that in Guyana?
Make the answer very short. 0.5. What is the ratio of the Taxes (in constant 2015 US$) of 1961 in Fiji to that in Guyana?
Provide a succinct answer. 0.48. What is the ratio of the Taxes (in constant 2015 US$) of 1962 in Fiji to that in Guyana?
Provide a short and direct response. 0.55. What is the ratio of the Taxes (in constant 2015 US$) of 1963 in Fiji to that in Guyana?
Offer a terse response. 0.68. What is the ratio of the Taxes (in constant 2015 US$) of 1960 in Fiji to that in Honduras?
Your answer should be very brief. 0.27. What is the ratio of the Taxes (in constant 2015 US$) of 1961 in Fiji to that in Honduras?
Provide a succinct answer. 0.26. What is the ratio of the Taxes (in constant 2015 US$) of 1962 in Fiji to that in Honduras?
Your answer should be very brief. 0.28. What is the ratio of the Taxes (in constant 2015 US$) in 1963 in Fiji to that in Honduras?
Offer a very short reply. 0.32. What is the ratio of the Taxes (in constant 2015 US$) of 1960 in Fiji to that in India?
Your response must be concise. 0. What is the ratio of the Taxes (in constant 2015 US$) of 1961 in Fiji to that in India?
Give a very brief answer. 0. What is the ratio of the Taxes (in constant 2015 US$) in 1962 in Fiji to that in India?
Your response must be concise. 0. What is the ratio of the Taxes (in constant 2015 US$) in 1963 in Fiji to that in India?
Make the answer very short. 0. What is the ratio of the Taxes (in constant 2015 US$) of 1960 in Guyana to that in Honduras?
Offer a very short reply. 0.53. What is the ratio of the Taxes (in constant 2015 US$) in 1961 in Guyana to that in Honduras?
Make the answer very short. 0.55. What is the ratio of the Taxes (in constant 2015 US$) in 1962 in Guyana to that in Honduras?
Your answer should be very brief. 0.5. What is the ratio of the Taxes (in constant 2015 US$) in 1963 in Guyana to that in Honduras?
Your answer should be compact. 0.47. What is the ratio of the Taxes (in constant 2015 US$) of 1960 in Guyana to that in India?
Make the answer very short. 0.01. What is the ratio of the Taxes (in constant 2015 US$) in 1961 in Guyana to that in India?
Make the answer very short. 0.01. What is the ratio of the Taxes (in constant 2015 US$) in 1962 in Guyana to that in India?
Your answer should be compact. 0.01. What is the ratio of the Taxes (in constant 2015 US$) of 1963 in Guyana to that in India?
Offer a terse response. 0.01. What is the ratio of the Taxes (in constant 2015 US$) in 1960 in Honduras to that in India?
Your response must be concise. 0.02. What is the ratio of the Taxes (in constant 2015 US$) of 1961 in Honduras to that in India?
Provide a short and direct response. 0.02. What is the ratio of the Taxes (in constant 2015 US$) of 1962 in Honduras to that in India?
Give a very brief answer. 0.01. What is the ratio of the Taxes (in constant 2015 US$) in 1963 in Honduras to that in India?
Offer a terse response. 0.01. What is the difference between the highest and the second highest Taxes (in constant 2015 US$) of 1960?
Your answer should be compact. 1.76e+09. What is the difference between the highest and the second highest Taxes (in constant 2015 US$) of 1961?
Keep it short and to the point. 2.04e+09. What is the difference between the highest and the second highest Taxes (in constant 2015 US$) of 1962?
Keep it short and to the point. 2.39e+09. What is the difference between the highest and the second highest Taxes (in constant 2015 US$) in 1963?
Give a very brief answer. 2.98e+09. What is the difference between the highest and the lowest Taxes (in constant 2015 US$) in 1960?
Offer a very short reply. 1.87e+09. What is the difference between the highest and the lowest Taxes (in constant 2015 US$) of 1961?
Ensure brevity in your answer.  2.13e+09. What is the difference between the highest and the lowest Taxes (in constant 2015 US$) of 1962?
Give a very brief answer. 2.49e+09. What is the difference between the highest and the lowest Taxes (in constant 2015 US$) in 1963?
Provide a succinct answer. 3.09e+09. 